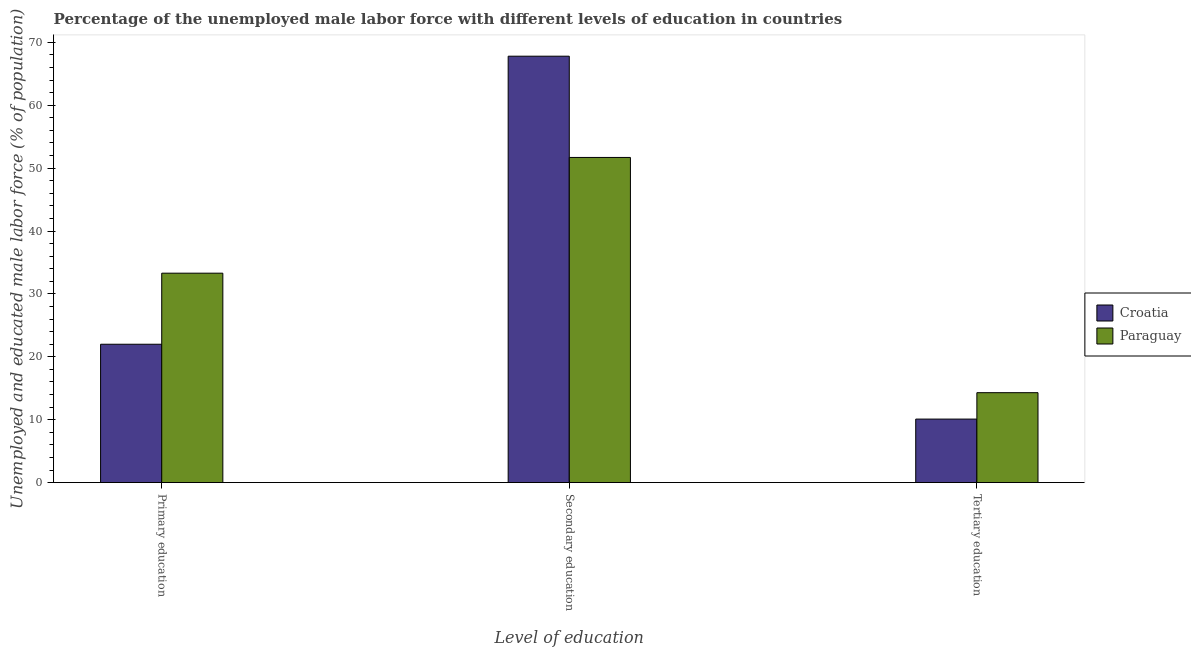How many groups of bars are there?
Provide a short and direct response. 3. Are the number of bars per tick equal to the number of legend labels?
Your answer should be very brief. Yes. Are the number of bars on each tick of the X-axis equal?
Your answer should be very brief. Yes. What is the label of the 3rd group of bars from the left?
Keep it short and to the point. Tertiary education. Across all countries, what is the maximum percentage of male labor force who received primary education?
Your response must be concise. 33.3. Across all countries, what is the minimum percentage of male labor force who received primary education?
Your answer should be compact. 22. In which country was the percentage of male labor force who received tertiary education maximum?
Make the answer very short. Paraguay. In which country was the percentage of male labor force who received tertiary education minimum?
Provide a succinct answer. Croatia. What is the total percentage of male labor force who received primary education in the graph?
Your answer should be very brief. 55.3. What is the difference between the percentage of male labor force who received primary education in Croatia and that in Paraguay?
Offer a terse response. -11.3. What is the difference between the percentage of male labor force who received secondary education in Croatia and the percentage of male labor force who received primary education in Paraguay?
Make the answer very short. 34.5. What is the average percentage of male labor force who received primary education per country?
Offer a terse response. 27.65. What is the difference between the percentage of male labor force who received secondary education and percentage of male labor force who received primary education in Croatia?
Offer a terse response. 45.8. In how many countries, is the percentage of male labor force who received primary education greater than 20 %?
Give a very brief answer. 2. What is the ratio of the percentage of male labor force who received tertiary education in Croatia to that in Paraguay?
Keep it short and to the point. 0.71. Is the percentage of male labor force who received secondary education in Paraguay less than that in Croatia?
Provide a short and direct response. Yes. What is the difference between the highest and the second highest percentage of male labor force who received primary education?
Give a very brief answer. 11.3. What is the difference between the highest and the lowest percentage of male labor force who received tertiary education?
Keep it short and to the point. 4.2. Is the sum of the percentage of male labor force who received secondary education in Paraguay and Croatia greater than the maximum percentage of male labor force who received primary education across all countries?
Your response must be concise. Yes. What does the 2nd bar from the left in Primary education represents?
Your response must be concise. Paraguay. What does the 1st bar from the right in Tertiary education represents?
Offer a very short reply. Paraguay. Is it the case that in every country, the sum of the percentage of male labor force who received primary education and percentage of male labor force who received secondary education is greater than the percentage of male labor force who received tertiary education?
Your response must be concise. Yes. How many bars are there?
Your response must be concise. 6. Are all the bars in the graph horizontal?
Your answer should be compact. No. Where does the legend appear in the graph?
Offer a very short reply. Center right. How many legend labels are there?
Give a very brief answer. 2. How are the legend labels stacked?
Keep it short and to the point. Vertical. What is the title of the graph?
Provide a short and direct response. Percentage of the unemployed male labor force with different levels of education in countries. What is the label or title of the X-axis?
Keep it short and to the point. Level of education. What is the label or title of the Y-axis?
Your answer should be compact. Unemployed and educated male labor force (% of population). What is the Unemployed and educated male labor force (% of population) in Croatia in Primary education?
Your response must be concise. 22. What is the Unemployed and educated male labor force (% of population) in Paraguay in Primary education?
Provide a short and direct response. 33.3. What is the Unemployed and educated male labor force (% of population) in Croatia in Secondary education?
Your response must be concise. 67.8. What is the Unemployed and educated male labor force (% of population) of Paraguay in Secondary education?
Offer a very short reply. 51.7. What is the Unemployed and educated male labor force (% of population) of Croatia in Tertiary education?
Your answer should be very brief. 10.1. What is the Unemployed and educated male labor force (% of population) in Paraguay in Tertiary education?
Your answer should be compact. 14.3. Across all Level of education, what is the maximum Unemployed and educated male labor force (% of population) of Croatia?
Offer a terse response. 67.8. Across all Level of education, what is the maximum Unemployed and educated male labor force (% of population) of Paraguay?
Your answer should be compact. 51.7. Across all Level of education, what is the minimum Unemployed and educated male labor force (% of population) of Croatia?
Your answer should be very brief. 10.1. Across all Level of education, what is the minimum Unemployed and educated male labor force (% of population) in Paraguay?
Offer a very short reply. 14.3. What is the total Unemployed and educated male labor force (% of population) in Croatia in the graph?
Your answer should be compact. 99.9. What is the total Unemployed and educated male labor force (% of population) of Paraguay in the graph?
Offer a terse response. 99.3. What is the difference between the Unemployed and educated male labor force (% of population) of Croatia in Primary education and that in Secondary education?
Keep it short and to the point. -45.8. What is the difference between the Unemployed and educated male labor force (% of population) of Paraguay in Primary education and that in Secondary education?
Provide a short and direct response. -18.4. What is the difference between the Unemployed and educated male labor force (% of population) in Croatia in Primary education and that in Tertiary education?
Give a very brief answer. 11.9. What is the difference between the Unemployed and educated male labor force (% of population) of Paraguay in Primary education and that in Tertiary education?
Provide a short and direct response. 19. What is the difference between the Unemployed and educated male labor force (% of population) of Croatia in Secondary education and that in Tertiary education?
Offer a terse response. 57.7. What is the difference between the Unemployed and educated male labor force (% of population) in Paraguay in Secondary education and that in Tertiary education?
Your answer should be compact. 37.4. What is the difference between the Unemployed and educated male labor force (% of population) in Croatia in Primary education and the Unemployed and educated male labor force (% of population) in Paraguay in Secondary education?
Offer a terse response. -29.7. What is the difference between the Unemployed and educated male labor force (% of population) of Croatia in Secondary education and the Unemployed and educated male labor force (% of population) of Paraguay in Tertiary education?
Provide a short and direct response. 53.5. What is the average Unemployed and educated male labor force (% of population) of Croatia per Level of education?
Ensure brevity in your answer.  33.3. What is the average Unemployed and educated male labor force (% of population) of Paraguay per Level of education?
Make the answer very short. 33.1. What is the difference between the Unemployed and educated male labor force (% of population) in Croatia and Unemployed and educated male labor force (% of population) in Paraguay in Tertiary education?
Your answer should be very brief. -4.2. What is the ratio of the Unemployed and educated male labor force (% of population) in Croatia in Primary education to that in Secondary education?
Keep it short and to the point. 0.32. What is the ratio of the Unemployed and educated male labor force (% of population) of Paraguay in Primary education to that in Secondary education?
Provide a short and direct response. 0.64. What is the ratio of the Unemployed and educated male labor force (% of population) in Croatia in Primary education to that in Tertiary education?
Give a very brief answer. 2.18. What is the ratio of the Unemployed and educated male labor force (% of population) of Paraguay in Primary education to that in Tertiary education?
Provide a succinct answer. 2.33. What is the ratio of the Unemployed and educated male labor force (% of population) in Croatia in Secondary education to that in Tertiary education?
Offer a terse response. 6.71. What is the ratio of the Unemployed and educated male labor force (% of population) in Paraguay in Secondary education to that in Tertiary education?
Make the answer very short. 3.62. What is the difference between the highest and the second highest Unemployed and educated male labor force (% of population) in Croatia?
Ensure brevity in your answer.  45.8. What is the difference between the highest and the second highest Unemployed and educated male labor force (% of population) of Paraguay?
Your answer should be very brief. 18.4. What is the difference between the highest and the lowest Unemployed and educated male labor force (% of population) in Croatia?
Make the answer very short. 57.7. What is the difference between the highest and the lowest Unemployed and educated male labor force (% of population) of Paraguay?
Your response must be concise. 37.4. 